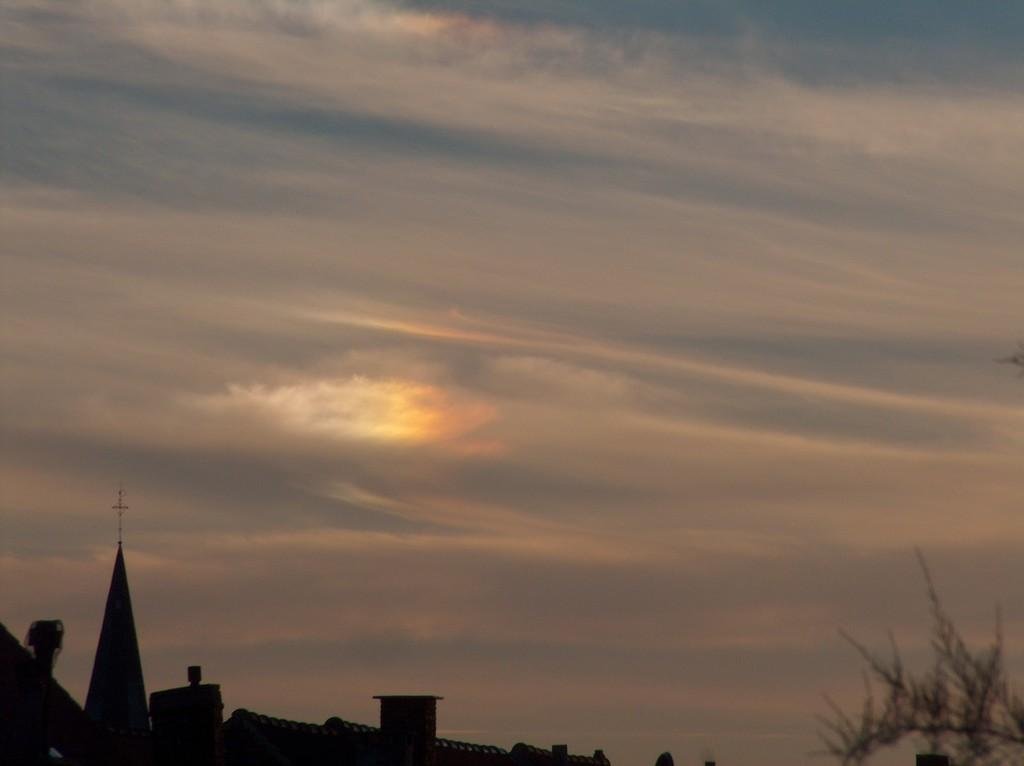What type of building is in the image? There is a church in the image. What other structures can be seen in the image? There are houses in the image. What type of plant is in the image? There is a tree in the image. What religious symbol is on top of the church? There is a cross on top of the church. What is the condition of the sky in the image? The sky is visible at the top of the image and appears to be cloudy. What language is spoken by the tree in the image? Trees do not speak languages, so this question cannot be answered. 